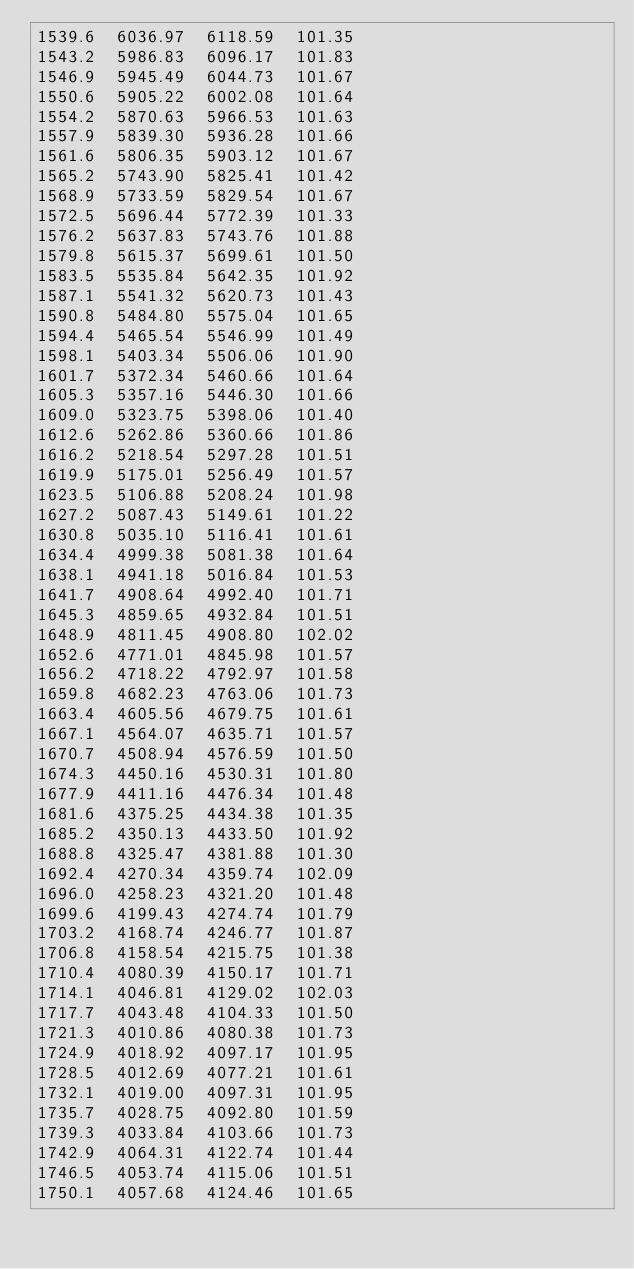<code> <loc_0><loc_0><loc_500><loc_500><_SML_>1539.6  6036.97  6118.59  101.35
1543.2  5986.83  6096.17  101.83
1546.9  5945.49  6044.73  101.67
1550.6  5905.22  6002.08  101.64
1554.2  5870.63  5966.53  101.63
1557.9  5839.30  5936.28  101.66
1561.6  5806.35  5903.12  101.67
1565.2  5743.90  5825.41  101.42
1568.9  5733.59  5829.54  101.67
1572.5  5696.44  5772.39  101.33
1576.2  5637.83  5743.76  101.88
1579.8  5615.37  5699.61  101.50
1583.5  5535.84  5642.35  101.92
1587.1  5541.32  5620.73  101.43
1590.8  5484.80  5575.04  101.65
1594.4  5465.54  5546.99  101.49
1598.1  5403.34  5506.06  101.90
1601.7  5372.34  5460.66  101.64
1605.3  5357.16  5446.30  101.66
1609.0  5323.75  5398.06  101.40
1612.6  5262.86  5360.66  101.86
1616.2  5218.54  5297.28  101.51
1619.9  5175.01  5256.49  101.57
1623.5  5106.88  5208.24  101.98
1627.2  5087.43  5149.61  101.22
1630.8  5035.10  5116.41  101.61
1634.4  4999.38  5081.38  101.64
1638.1  4941.18  5016.84  101.53
1641.7  4908.64  4992.40  101.71
1645.3  4859.65  4932.84  101.51
1648.9  4811.45  4908.80  102.02
1652.6  4771.01  4845.98  101.57
1656.2  4718.22  4792.97  101.58
1659.8  4682.23  4763.06  101.73
1663.4  4605.56  4679.75  101.61
1667.1  4564.07  4635.71  101.57
1670.7  4508.94  4576.59  101.50
1674.3  4450.16  4530.31  101.80
1677.9  4411.16  4476.34  101.48
1681.6  4375.25  4434.38  101.35
1685.2  4350.13  4433.50  101.92
1688.8  4325.47  4381.88  101.30
1692.4  4270.34  4359.74  102.09
1696.0  4258.23  4321.20  101.48
1699.6  4199.43  4274.74  101.79
1703.2  4168.74  4246.77  101.87
1706.8  4158.54  4215.75  101.38
1710.4  4080.39  4150.17  101.71
1714.1  4046.81  4129.02  102.03
1717.7  4043.48  4104.33  101.50
1721.3  4010.86  4080.38  101.73
1724.9  4018.92  4097.17  101.95
1728.5  4012.69  4077.21  101.61
1732.1  4019.00  4097.31  101.95
1735.7  4028.75  4092.80  101.59
1739.3  4033.84  4103.66  101.73
1742.9  4064.31  4122.74  101.44
1746.5  4053.74  4115.06  101.51
1750.1  4057.68  4124.46  101.65</code> 